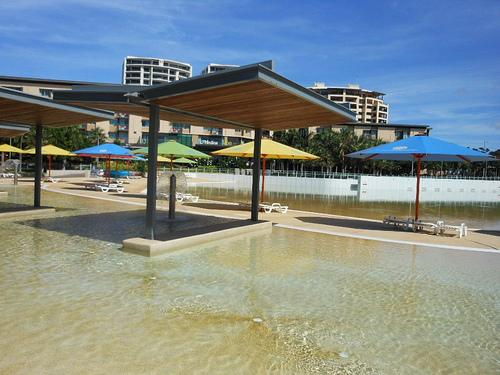Write a sentence summarizing the main theme of the image. This image captures a serene beach-like setting with a man-made pool, shaded areas, and colorful umbrellas, creating a relaxing and inviting atmosphere. Discuss the most eye-catching aspects of this image. The most eye-catching aspects include the clear, shallow water that mimics a beach, the vibrant blue and yellow umbrellas, and the modern shaded structures that provide a comfortable lounging area. Outline the most distinguishable elements seen in the image. The image features a man-made beach pool, colorful umbrellas in blue and yellow, shaded lounge areas, and a backdrop of a hotel and palm trees. Write a succinct description of the central focus of the image. The central focus of the image is the artificial beach setting with its clear shallow water, colorful umbrellas, and shaded seating areas, all designed for relaxation. Using a poetic tone, describe the atmosphere conveyed by the image. Beneath the azure sky, a crafted oasis lies with waters clear as crystal and umbrellas blooming like summer flowers, offering a slice of paradise under the watchful eyes of towering palms. Describe the image in the style of a luxury advertisement. Experience the ultimate in relaxation at our exclusive beach-inspired pool, complete with luxurious loungers under chic shades and vibrant umbrellas, all set against the backdrop of our prestigious resort. In the style of a travel magazine, give a description that features this image. Discover a unique getaway at our resort's beach-style pool, where you can soak in the sun under colorful umbrellas and unwind in stylishly shaded loungers, all while enjoying the amenities of a top-tier hotel. Summarize the image in brief by highlighting its key points. The image showcases a man-made beach setting with clear shallow water, colorful umbrellas, shaded areas for relaxation, and a hotel in the background. Mention the notable components in the image and their interaction with each other. The man-made beach pool, vibrant umbrellas, and modern shaded lounging areas create a harmonious and inviting leisure space, complemented by the hotel and palm trees in the background. Pretend you are a child describing the image for the first time. Wow, look at the cool water that looks like a beach and the big colorful umbrellas! There are places to sit in the shade, and it's all right by a big building! 